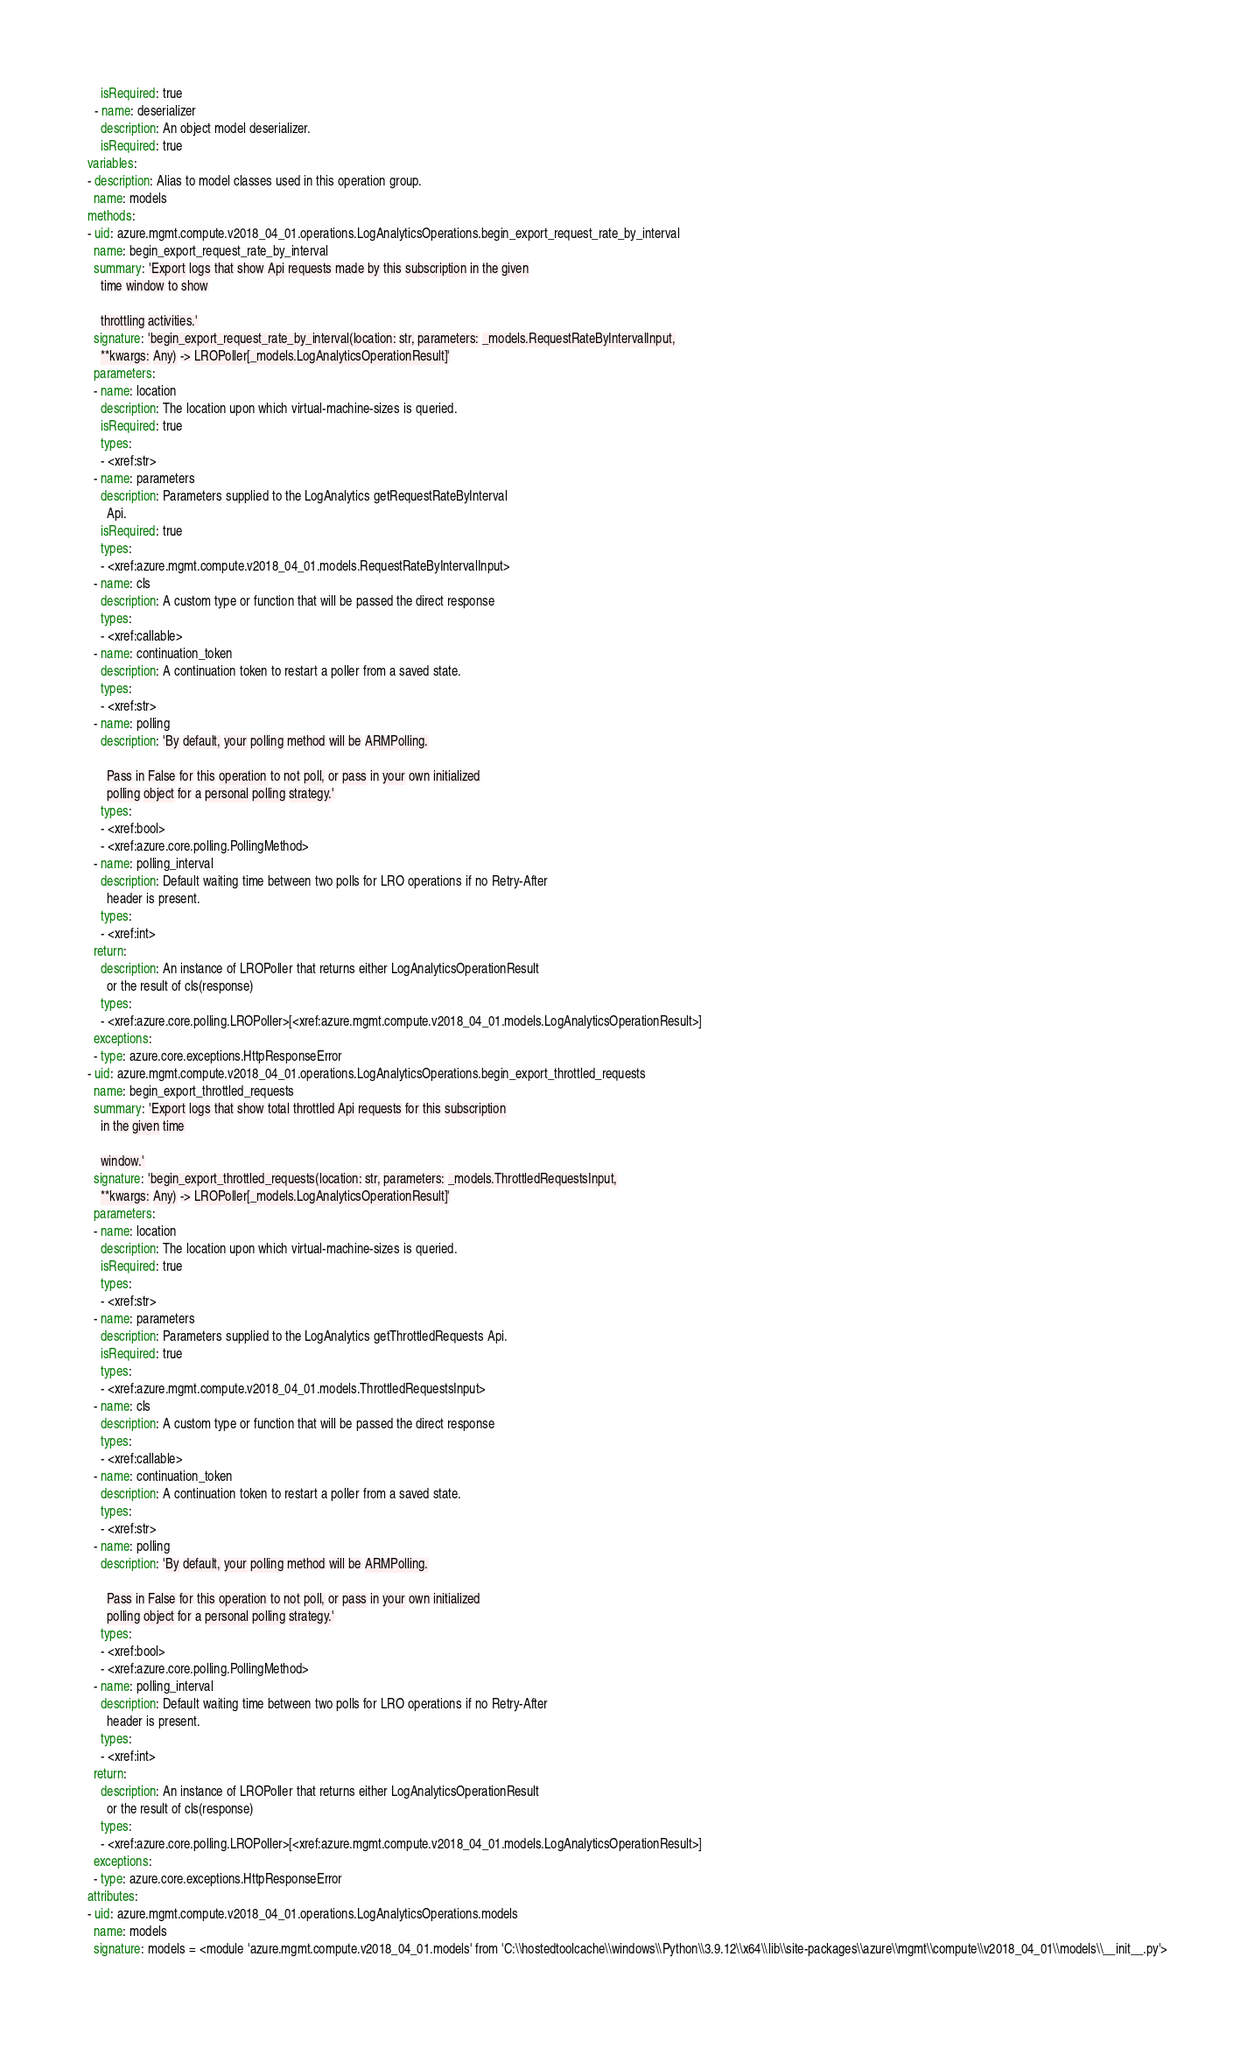Convert code to text. <code><loc_0><loc_0><loc_500><loc_500><_YAML_>    isRequired: true
  - name: deserializer
    description: An object model deserializer.
    isRequired: true
variables:
- description: Alias to model classes used in this operation group.
  name: models
methods:
- uid: azure.mgmt.compute.v2018_04_01.operations.LogAnalyticsOperations.begin_export_request_rate_by_interval
  name: begin_export_request_rate_by_interval
  summary: 'Export logs that show Api requests made by this subscription in the given
    time window to show

    throttling activities.'
  signature: 'begin_export_request_rate_by_interval(location: str, parameters: _models.RequestRateByIntervalInput,
    **kwargs: Any) -> LROPoller[_models.LogAnalyticsOperationResult]'
  parameters:
  - name: location
    description: The location upon which virtual-machine-sizes is queried.
    isRequired: true
    types:
    - <xref:str>
  - name: parameters
    description: Parameters supplied to the LogAnalytics getRequestRateByInterval
      Api.
    isRequired: true
    types:
    - <xref:azure.mgmt.compute.v2018_04_01.models.RequestRateByIntervalInput>
  - name: cls
    description: A custom type or function that will be passed the direct response
    types:
    - <xref:callable>
  - name: continuation_token
    description: A continuation token to restart a poller from a saved state.
    types:
    - <xref:str>
  - name: polling
    description: 'By default, your polling method will be ARMPolling.

      Pass in False for this operation to not poll, or pass in your own initialized
      polling object for a personal polling strategy.'
    types:
    - <xref:bool>
    - <xref:azure.core.polling.PollingMethod>
  - name: polling_interval
    description: Default waiting time between two polls for LRO operations if no Retry-After
      header is present.
    types:
    - <xref:int>
  return:
    description: An instance of LROPoller that returns either LogAnalyticsOperationResult
      or the result of cls(response)
    types:
    - <xref:azure.core.polling.LROPoller>[<xref:azure.mgmt.compute.v2018_04_01.models.LogAnalyticsOperationResult>]
  exceptions:
  - type: azure.core.exceptions.HttpResponseError
- uid: azure.mgmt.compute.v2018_04_01.operations.LogAnalyticsOperations.begin_export_throttled_requests
  name: begin_export_throttled_requests
  summary: 'Export logs that show total throttled Api requests for this subscription
    in the given time

    window.'
  signature: 'begin_export_throttled_requests(location: str, parameters: _models.ThrottledRequestsInput,
    **kwargs: Any) -> LROPoller[_models.LogAnalyticsOperationResult]'
  parameters:
  - name: location
    description: The location upon which virtual-machine-sizes is queried.
    isRequired: true
    types:
    - <xref:str>
  - name: parameters
    description: Parameters supplied to the LogAnalytics getThrottledRequests Api.
    isRequired: true
    types:
    - <xref:azure.mgmt.compute.v2018_04_01.models.ThrottledRequestsInput>
  - name: cls
    description: A custom type or function that will be passed the direct response
    types:
    - <xref:callable>
  - name: continuation_token
    description: A continuation token to restart a poller from a saved state.
    types:
    - <xref:str>
  - name: polling
    description: 'By default, your polling method will be ARMPolling.

      Pass in False for this operation to not poll, or pass in your own initialized
      polling object for a personal polling strategy.'
    types:
    - <xref:bool>
    - <xref:azure.core.polling.PollingMethod>
  - name: polling_interval
    description: Default waiting time between two polls for LRO operations if no Retry-After
      header is present.
    types:
    - <xref:int>
  return:
    description: An instance of LROPoller that returns either LogAnalyticsOperationResult
      or the result of cls(response)
    types:
    - <xref:azure.core.polling.LROPoller>[<xref:azure.mgmt.compute.v2018_04_01.models.LogAnalyticsOperationResult>]
  exceptions:
  - type: azure.core.exceptions.HttpResponseError
attributes:
- uid: azure.mgmt.compute.v2018_04_01.operations.LogAnalyticsOperations.models
  name: models
  signature: models = <module 'azure.mgmt.compute.v2018_04_01.models' from 'C:\\hostedtoolcache\\windows\\Python\\3.9.12\\x64\\lib\\site-packages\\azure\\mgmt\\compute\\v2018_04_01\\models\\__init__.py'>
</code> 